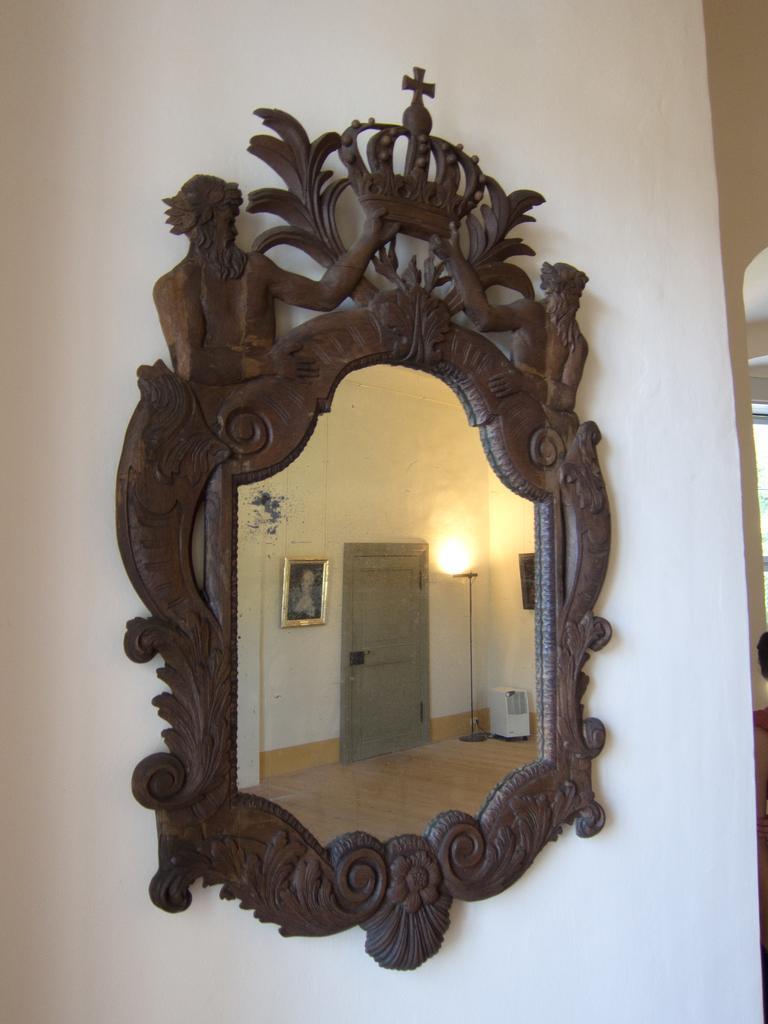In one or two sentences, can you explain what this image depicts? In this image I can see the white colored wall to which I can see a mirror frame which is brown in color and the mirror. In the mirror I can see the reflection of the floor, the door, the wall, a photo frame and a lamp. 